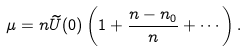Convert formula to latex. <formula><loc_0><loc_0><loc_500><loc_500>\mu = n \widetilde { U } ( 0 ) \left ( 1 + \frac { n - n _ { 0 } } { n } + \cdots \right ) .</formula> 